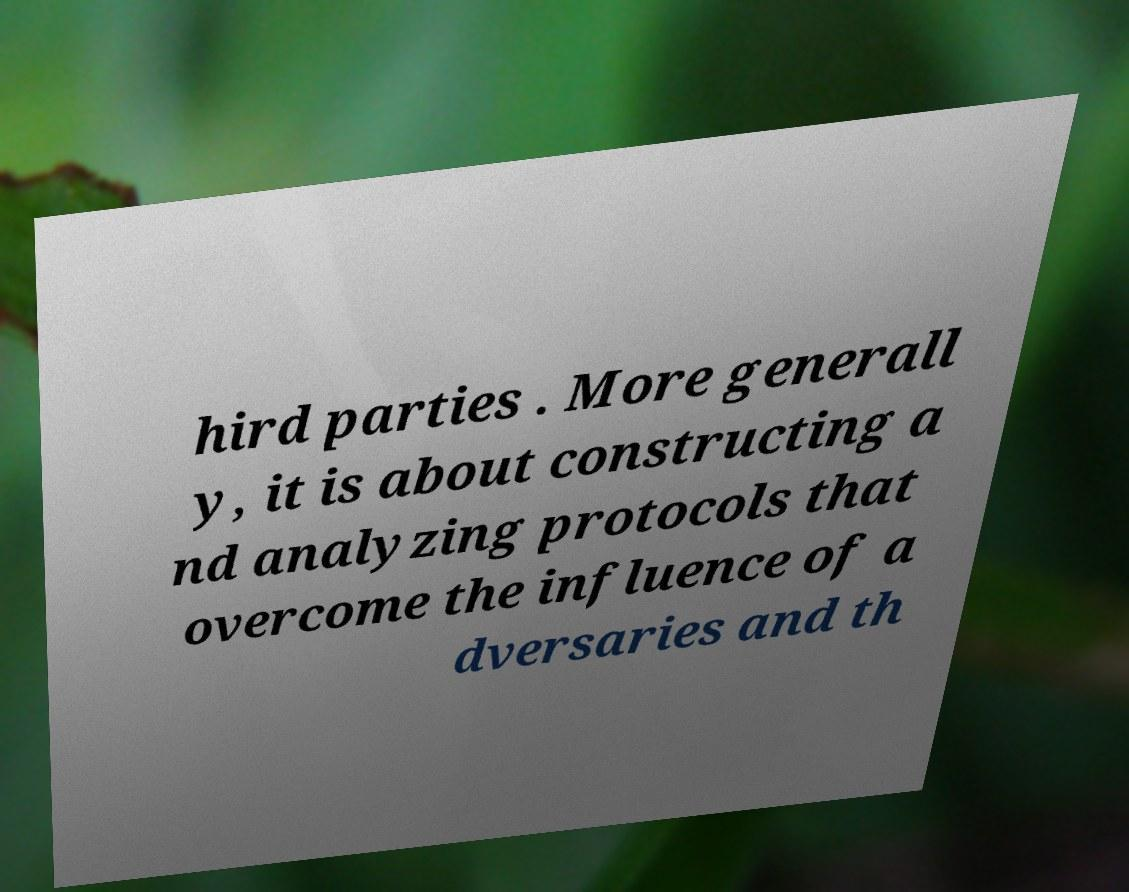Can you read and provide the text displayed in the image?This photo seems to have some interesting text. Can you extract and type it out for me? hird parties . More generall y, it is about constructing a nd analyzing protocols that overcome the influence of a dversaries and th 